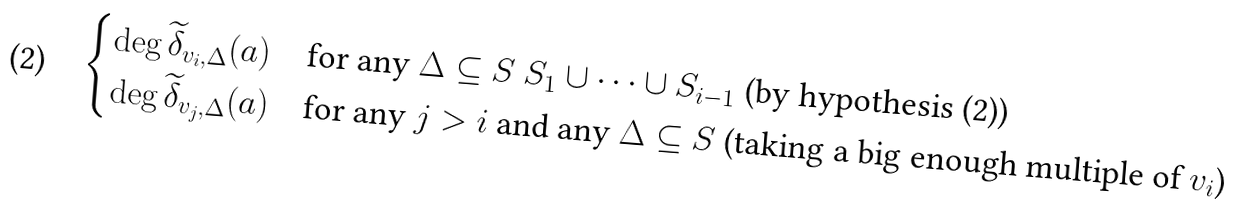<formula> <loc_0><loc_0><loc_500><loc_500>\begin{cases} \deg \widetilde { \delta } _ { v _ { i } , \Delta } ( a ) & \text {for any $\Delta\subseteq   S\ S_{1}\cup\dots\cup S_{i-1}$} \text { (by hypothesis (2))} \\ \deg \widetilde { \delta } _ { v _ { j } , \Delta } ( a ) & \text {for any $j>i$ and any $\Delta\subseteq S$ (taking a big enough multiple of $v_{i}$)} \end{cases}</formula> 